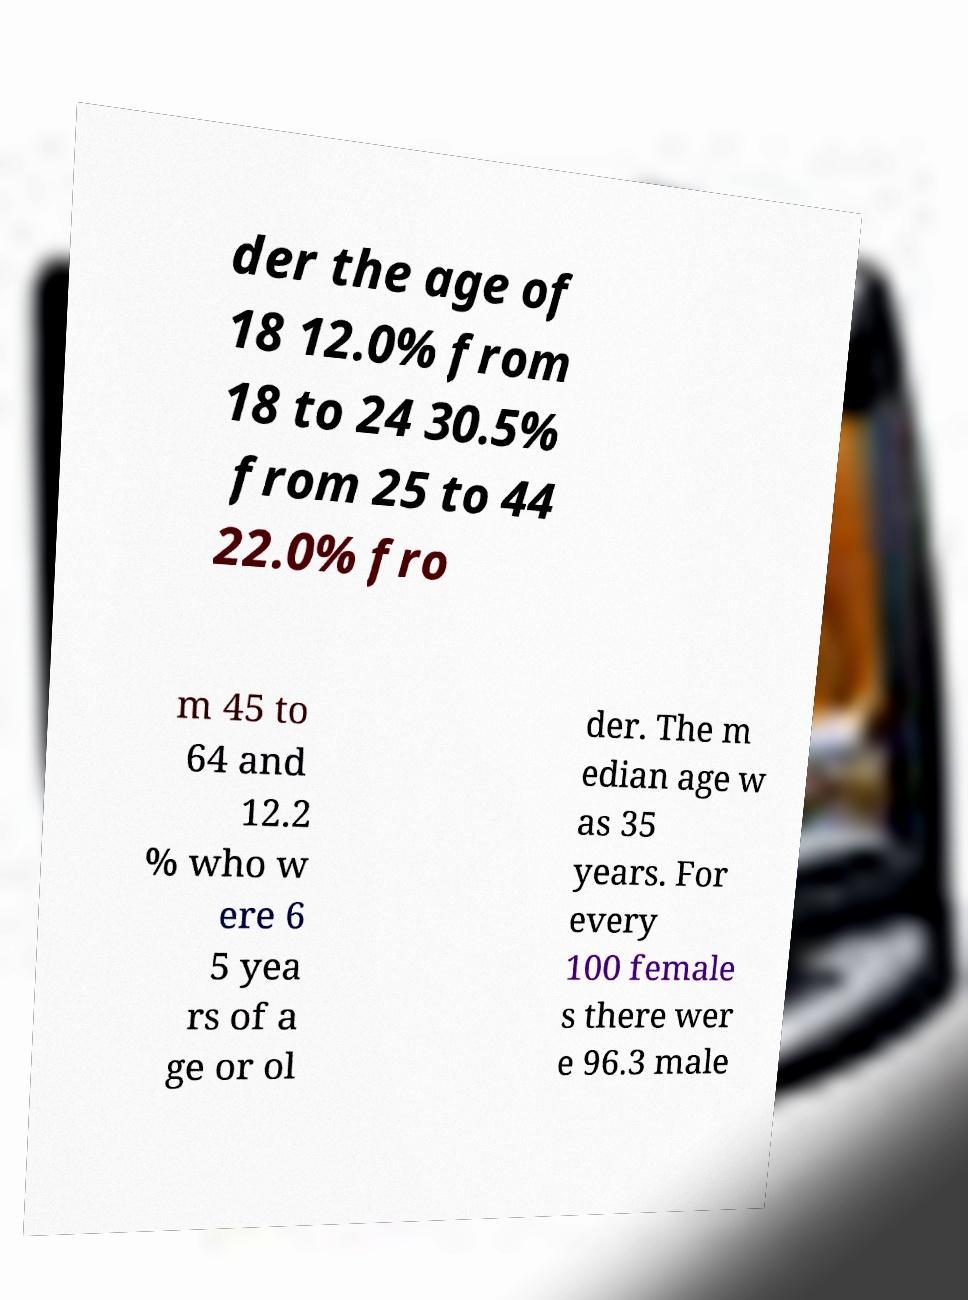Can you accurately transcribe the text from the provided image for me? der the age of 18 12.0% from 18 to 24 30.5% from 25 to 44 22.0% fro m 45 to 64 and 12.2 % who w ere 6 5 yea rs of a ge or ol der. The m edian age w as 35 years. For every 100 female s there wer e 96.3 male 